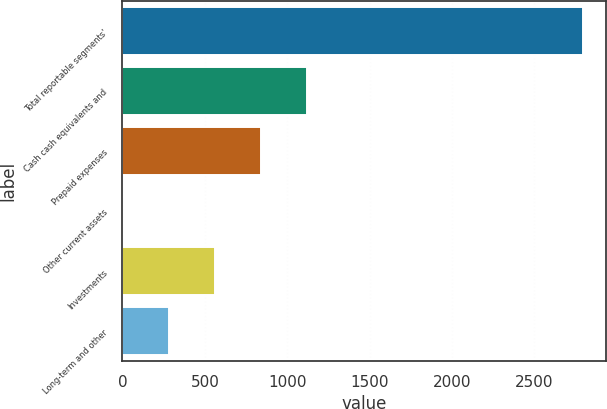Convert chart to OTSL. <chart><loc_0><loc_0><loc_500><loc_500><bar_chart><fcel>Total reportable segments'<fcel>Cash cash equivalents and<fcel>Prepaid expenses<fcel>Other current assets<fcel>Investments<fcel>Long-term and other<nl><fcel>2796<fcel>1119.6<fcel>840.2<fcel>2<fcel>560.8<fcel>281.4<nl></chart> 